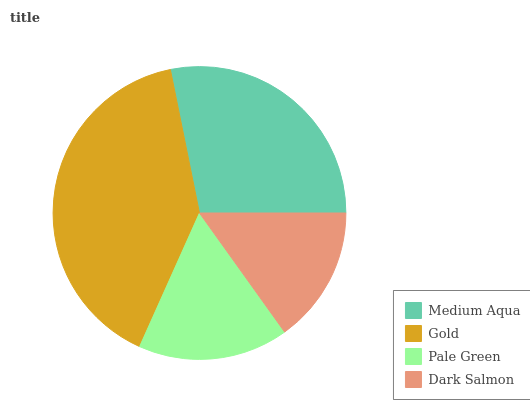Is Dark Salmon the minimum?
Answer yes or no. Yes. Is Gold the maximum?
Answer yes or no. Yes. Is Pale Green the minimum?
Answer yes or no. No. Is Pale Green the maximum?
Answer yes or no. No. Is Gold greater than Pale Green?
Answer yes or no. Yes. Is Pale Green less than Gold?
Answer yes or no. Yes. Is Pale Green greater than Gold?
Answer yes or no. No. Is Gold less than Pale Green?
Answer yes or no. No. Is Medium Aqua the high median?
Answer yes or no. Yes. Is Pale Green the low median?
Answer yes or no. Yes. Is Dark Salmon the high median?
Answer yes or no. No. Is Medium Aqua the low median?
Answer yes or no. No. 